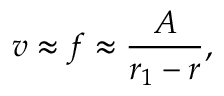<formula> <loc_0><loc_0><loc_500><loc_500>v \approx f \approx \frac { A } { r _ { 1 } - r } ,</formula> 